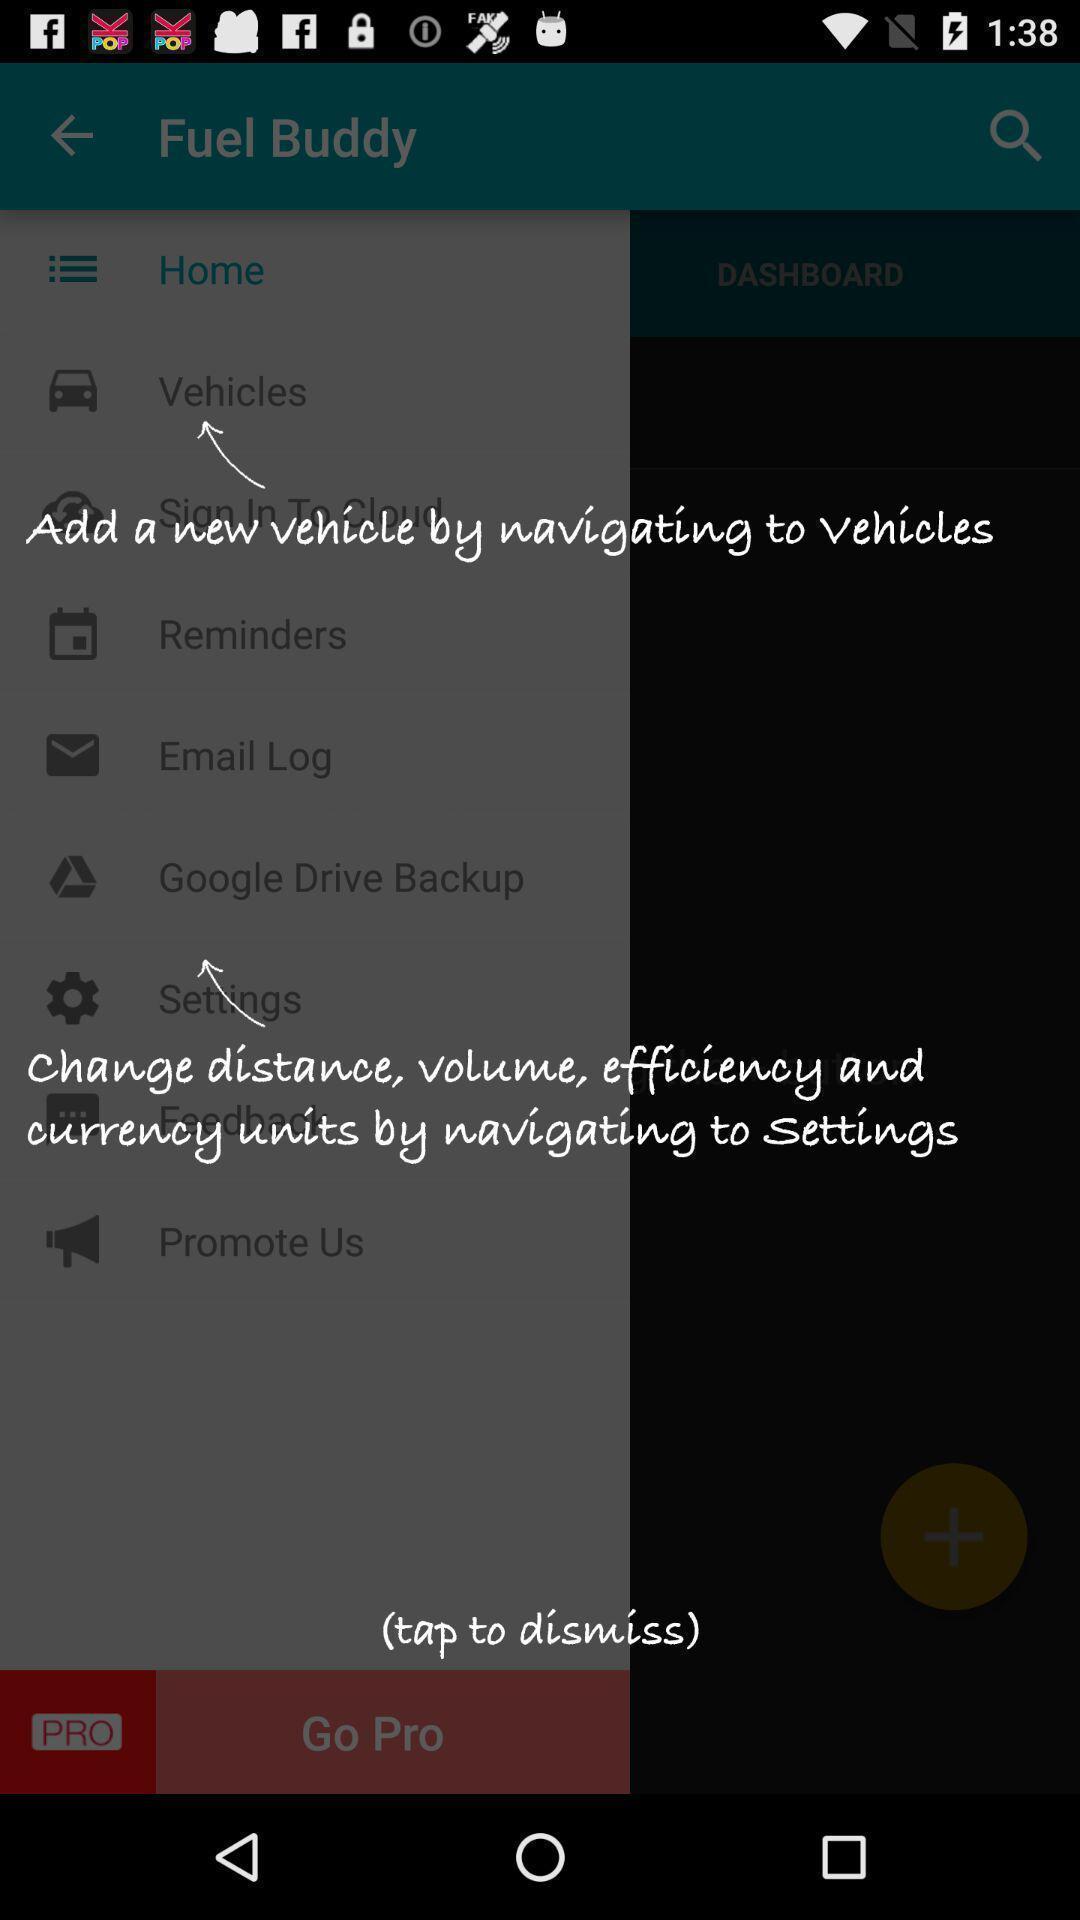Describe this image in words. Pop up showing the instructions. 